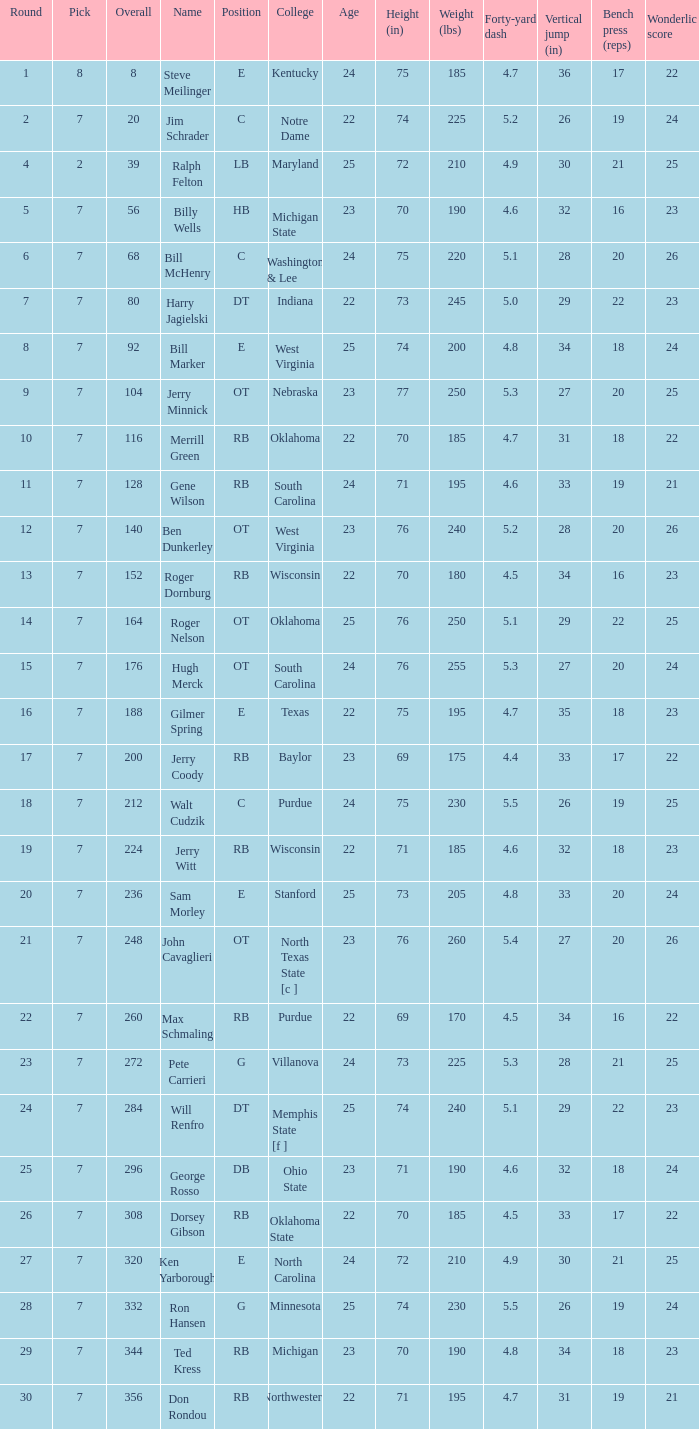What is the number of the round in which Ron Hansen was drafted and the overall is greater than 332? 0.0. 